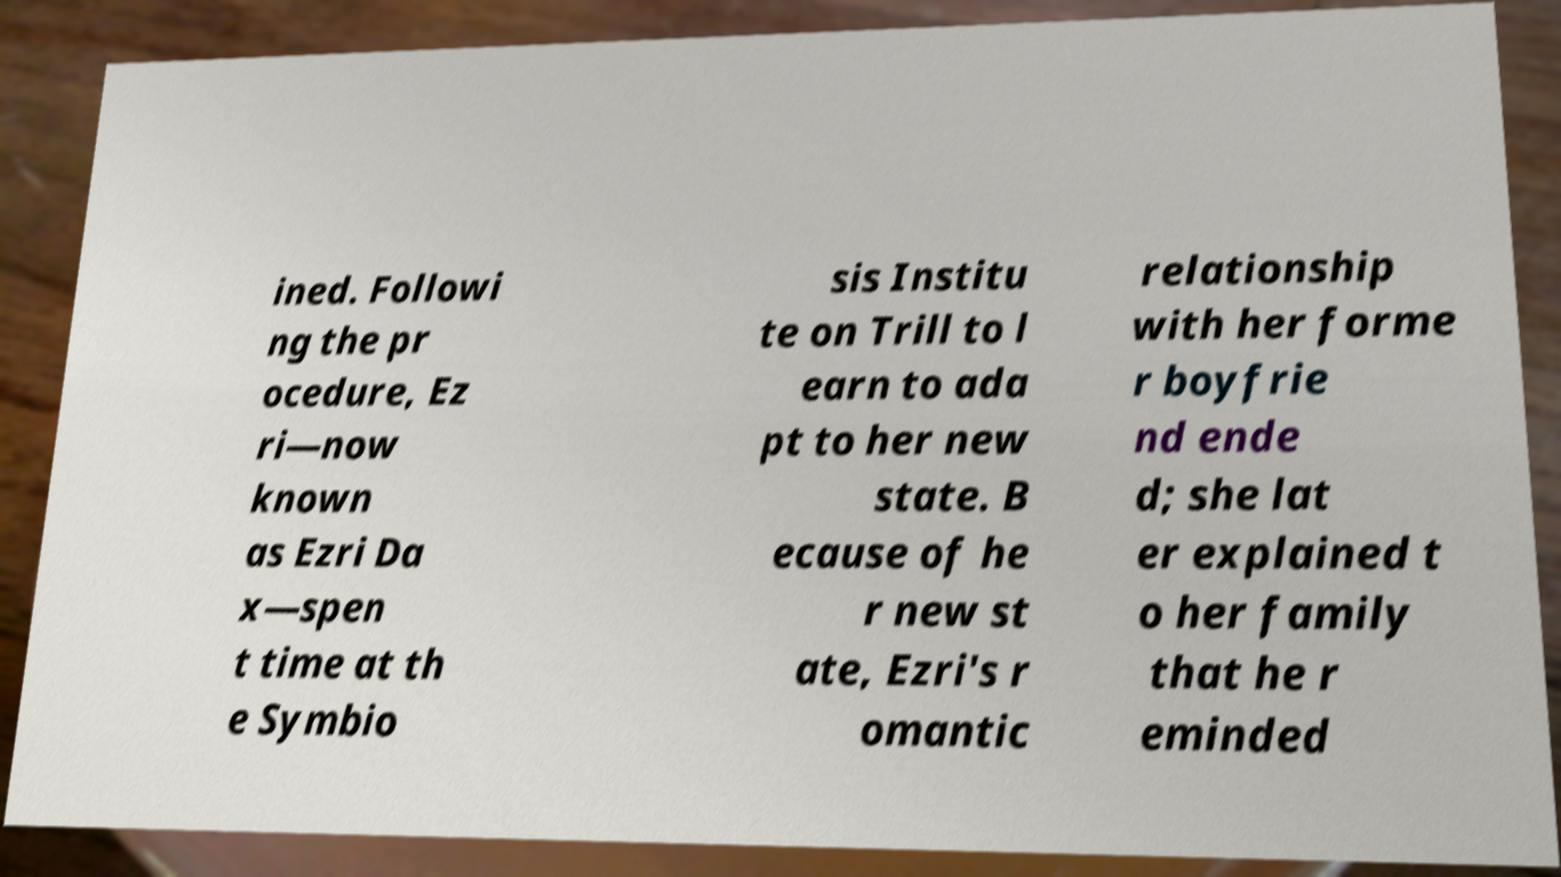Can you read and provide the text displayed in the image?This photo seems to have some interesting text. Can you extract and type it out for me? ined. Followi ng the pr ocedure, Ez ri—now known as Ezri Da x—spen t time at th e Symbio sis Institu te on Trill to l earn to ada pt to her new state. B ecause of he r new st ate, Ezri's r omantic relationship with her forme r boyfrie nd ende d; she lat er explained t o her family that he r eminded 